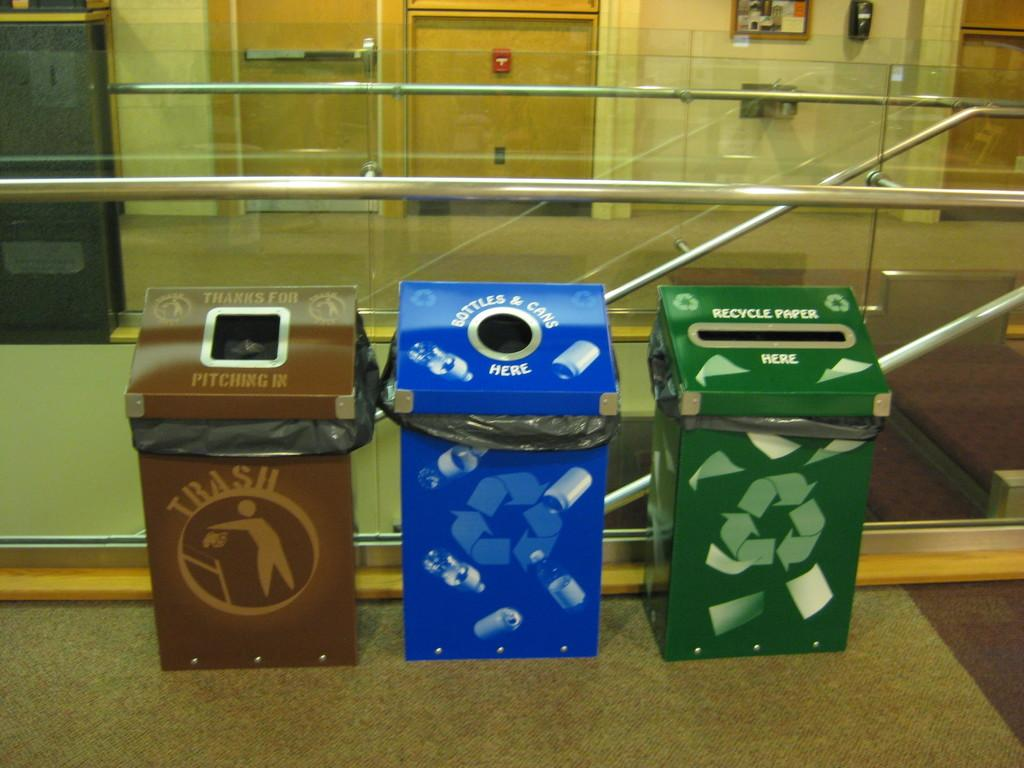Provide a one-sentence caption for the provided image. A brown trash bin, a blue bottles and cans recycling bin, and a green paper recycling bin in front of a glass and metal stair way. 